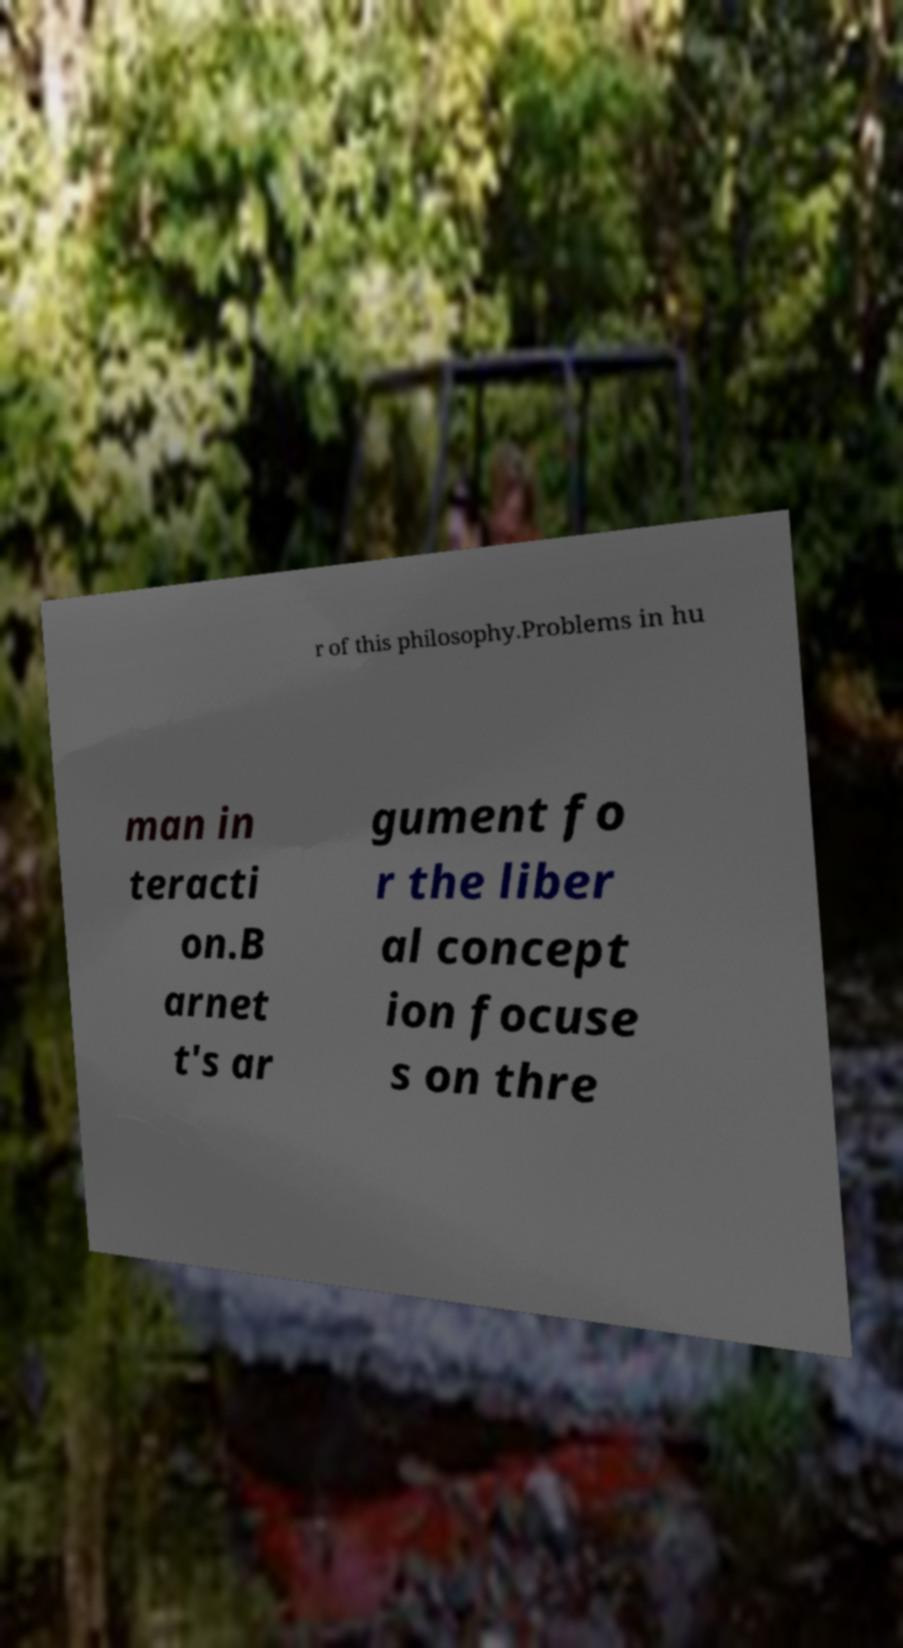Please read and relay the text visible in this image. What does it say? r of this philosophy.Problems in hu man in teracti on.B arnet t's ar gument fo r the liber al concept ion focuse s on thre 